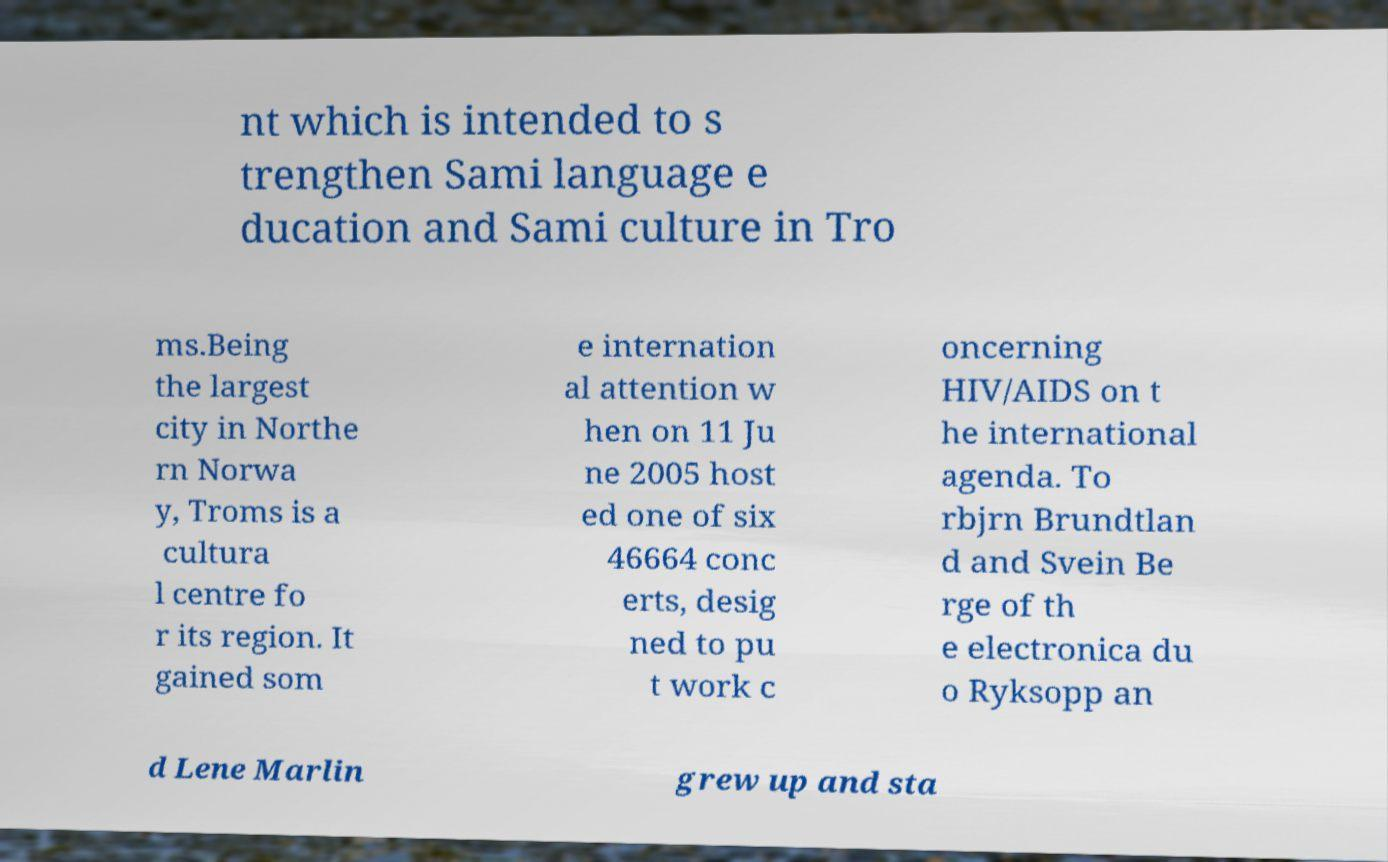For documentation purposes, I need the text within this image transcribed. Could you provide that? nt which is intended to s trengthen Sami language e ducation and Sami culture in Tro ms.Being the largest city in Northe rn Norwa y, Troms is a cultura l centre fo r its region. It gained som e internation al attention w hen on 11 Ju ne 2005 host ed one of six 46664 conc erts, desig ned to pu t work c oncerning HIV/AIDS on t he international agenda. To rbjrn Brundtlan d and Svein Be rge of th e electronica du o Ryksopp an d Lene Marlin grew up and sta 